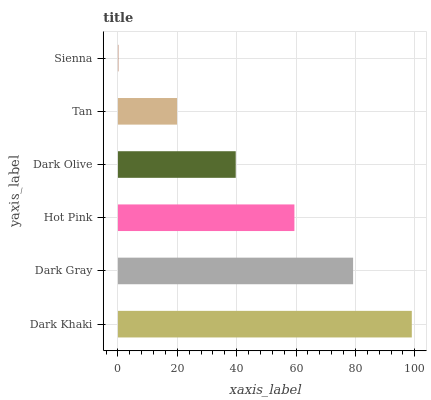Is Sienna the minimum?
Answer yes or no. Yes. Is Dark Khaki the maximum?
Answer yes or no. Yes. Is Dark Gray the minimum?
Answer yes or no. No. Is Dark Gray the maximum?
Answer yes or no. No. Is Dark Khaki greater than Dark Gray?
Answer yes or no. Yes. Is Dark Gray less than Dark Khaki?
Answer yes or no. Yes. Is Dark Gray greater than Dark Khaki?
Answer yes or no. No. Is Dark Khaki less than Dark Gray?
Answer yes or no. No. Is Hot Pink the high median?
Answer yes or no. Yes. Is Dark Olive the low median?
Answer yes or no. Yes. Is Sienna the high median?
Answer yes or no. No. Is Sienna the low median?
Answer yes or no. No. 